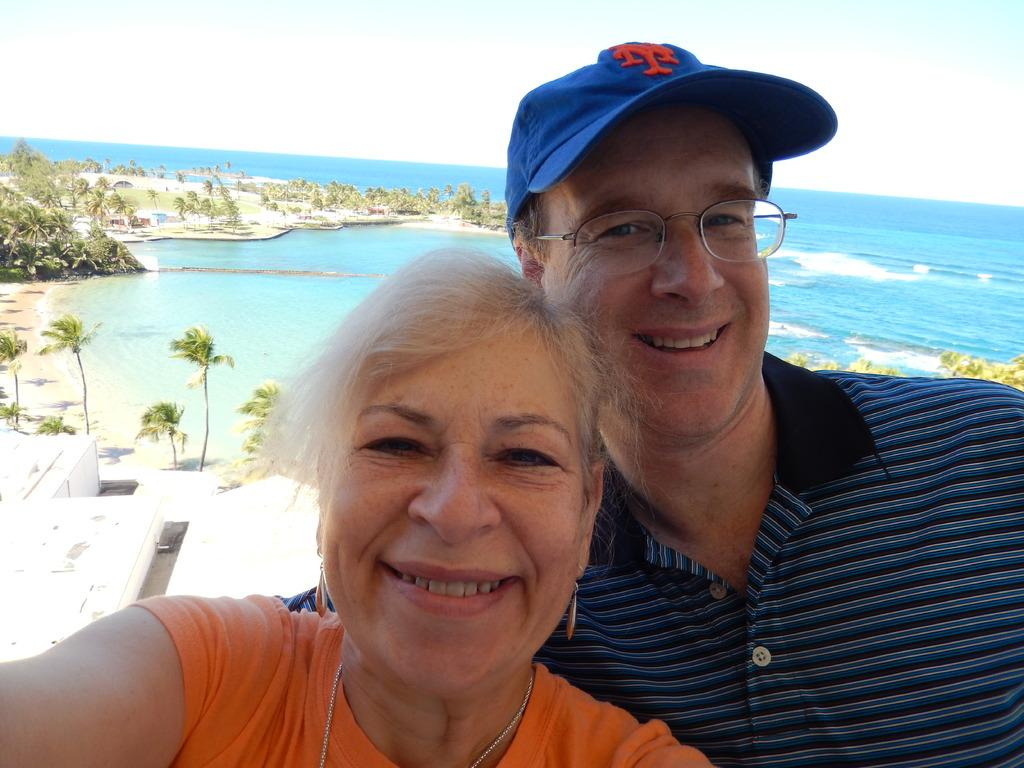Who is present in the image? There is a man and a woman in the image. What expressions do the man and woman have? Both the man and the woman are smiling. Can you describe the man's appearance? The man is wearing spectacles and a cap. What can be seen in the background of the image? There is water, trees, at least one building, and the sky visible in the background of the image. What type of jewel is the man holding in the image? There is no jewel present in the image; the man is not holding anything. What color is the sky in the image? The provided facts do not mention the color of the sky, only that it is visible in the background of the image. 